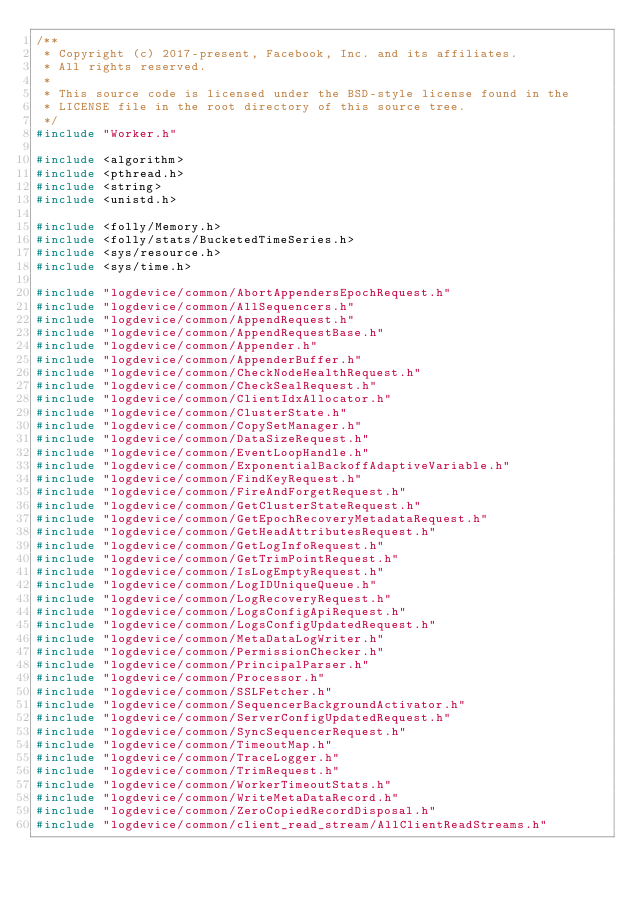<code> <loc_0><loc_0><loc_500><loc_500><_C++_>/**
 * Copyright (c) 2017-present, Facebook, Inc. and its affiliates.
 * All rights reserved.
 *
 * This source code is licensed under the BSD-style license found in the
 * LICENSE file in the root directory of this source tree.
 */
#include "Worker.h"

#include <algorithm>
#include <pthread.h>
#include <string>
#include <unistd.h>

#include <folly/Memory.h>
#include <folly/stats/BucketedTimeSeries.h>
#include <sys/resource.h>
#include <sys/time.h>

#include "logdevice/common/AbortAppendersEpochRequest.h"
#include "logdevice/common/AllSequencers.h"
#include "logdevice/common/AppendRequest.h"
#include "logdevice/common/AppendRequestBase.h"
#include "logdevice/common/Appender.h"
#include "logdevice/common/AppenderBuffer.h"
#include "logdevice/common/CheckNodeHealthRequest.h"
#include "logdevice/common/CheckSealRequest.h"
#include "logdevice/common/ClientIdxAllocator.h"
#include "logdevice/common/ClusterState.h"
#include "logdevice/common/CopySetManager.h"
#include "logdevice/common/DataSizeRequest.h"
#include "logdevice/common/EventLoopHandle.h"
#include "logdevice/common/ExponentialBackoffAdaptiveVariable.h"
#include "logdevice/common/FindKeyRequest.h"
#include "logdevice/common/FireAndForgetRequest.h"
#include "logdevice/common/GetClusterStateRequest.h"
#include "logdevice/common/GetEpochRecoveryMetadataRequest.h"
#include "logdevice/common/GetHeadAttributesRequest.h"
#include "logdevice/common/GetLogInfoRequest.h"
#include "logdevice/common/GetTrimPointRequest.h"
#include "logdevice/common/IsLogEmptyRequest.h"
#include "logdevice/common/LogIDUniqueQueue.h"
#include "logdevice/common/LogRecoveryRequest.h"
#include "logdevice/common/LogsConfigApiRequest.h"
#include "logdevice/common/LogsConfigUpdatedRequest.h"
#include "logdevice/common/MetaDataLogWriter.h"
#include "logdevice/common/PermissionChecker.h"
#include "logdevice/common/PrincipalParser.h"
#include "logdevice/common/Processor.h"
#include "logdevice/common/SSLFetcher.h"
#include "logdevice/common/SequencerBackgroundActivator.h"
#include "logdevice/common/ServerConfigUpdatedRequest.h"
#include "logdevice/common/SyncSequencerRequest.h"
#include "logdevice/common/TimeoutMap.h"
#include "logdevice/common/TraceLogger.h"
#include "logdevice/common/TrimRequest.h"
#include "logdevice/common/WorkerTimeoutStats.h"
#include "logdevice/common/WriteMetaDataRecord.h"
#include "logdevice/common/ZeroCopiedRecordDisposal.h"
#include "logdevice/common/client_read_stream/AllClientReadStreams.h"</code> 